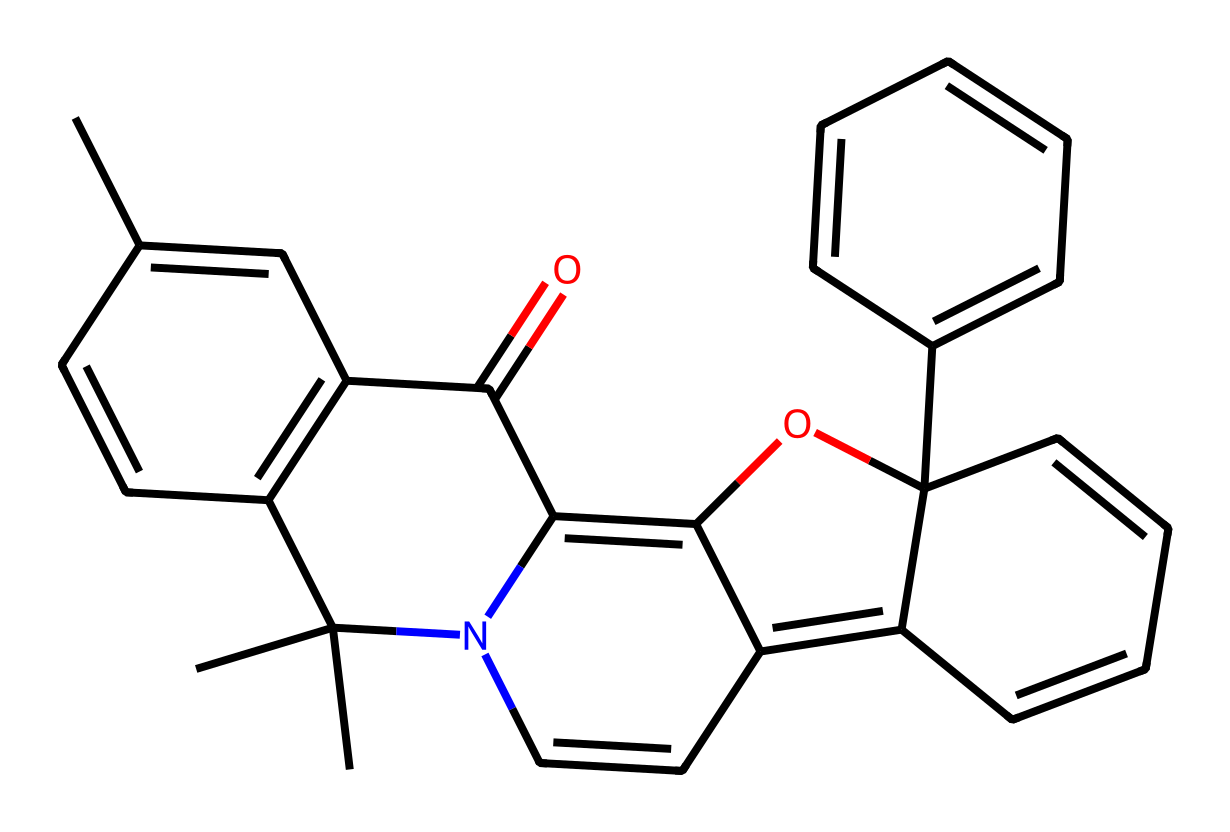What is the molecular formula of the spiropyran molecule represented by the SMILES? By analyzing the SMILES, we can count the number of carbon (C), hydrogen (H), nitrogen (N), and oxygen (O) atoms. From the structure provided, we find there are 20 carbon atoms, 21 hydrogen atoms, 1 nitrogen atom, and 1 oxygen atom, leading to the molecular formula C20H21N1O1.
Answer: C20H21N1O1 How many rings are present in the spiropyran structure? Inspecting the SMILES reveals multiple cyclic structures within the molecule. By carefully examining the elements and their connections in the structure, it is determined that there are four distinct rings present in the spiropyran.
Answer: 4 What functional groups can be identified in the spiropyran molecule? In the provided SMILES, we can identify a methoxy group (-OCH3) and a carbonyl group (C=O) in the structure. These functional groups are commonly associated with photoreactive properties, contributing to its responsiveness to light.
Answer: methoxy and carbonyl What kind of reactions can spiropyran molecules undergo upon light exposure? Spiropyran molecules are known for their reversible photochromic behavior, meaning they can switch between different forms when exposed to light, leading to an alteration in their molecular structure. This behavior is crucial for their application in data encryption systems.
Answer: photoisomerization What role does the nitrogen atom play in the spiropyran molecule's structure? The presence of the nitrogen atom in the spiropyran molecule indicates that it can act as a chelating site or a potential point for protonation or deprotonation under varying pH conditions. This makes the nitrogen a key component in influencing the molecule's photoreactivity and stability.
Answer: protonation site What property makes spiropyran suitable for light-responsive data encryption systems? The ability of spiropyran to undergo reversible structural changes upon light exposure allows it to store and erase information, making it suitable for applications in data encryption systems where security is paramount.
Answer: reversible structural changes 